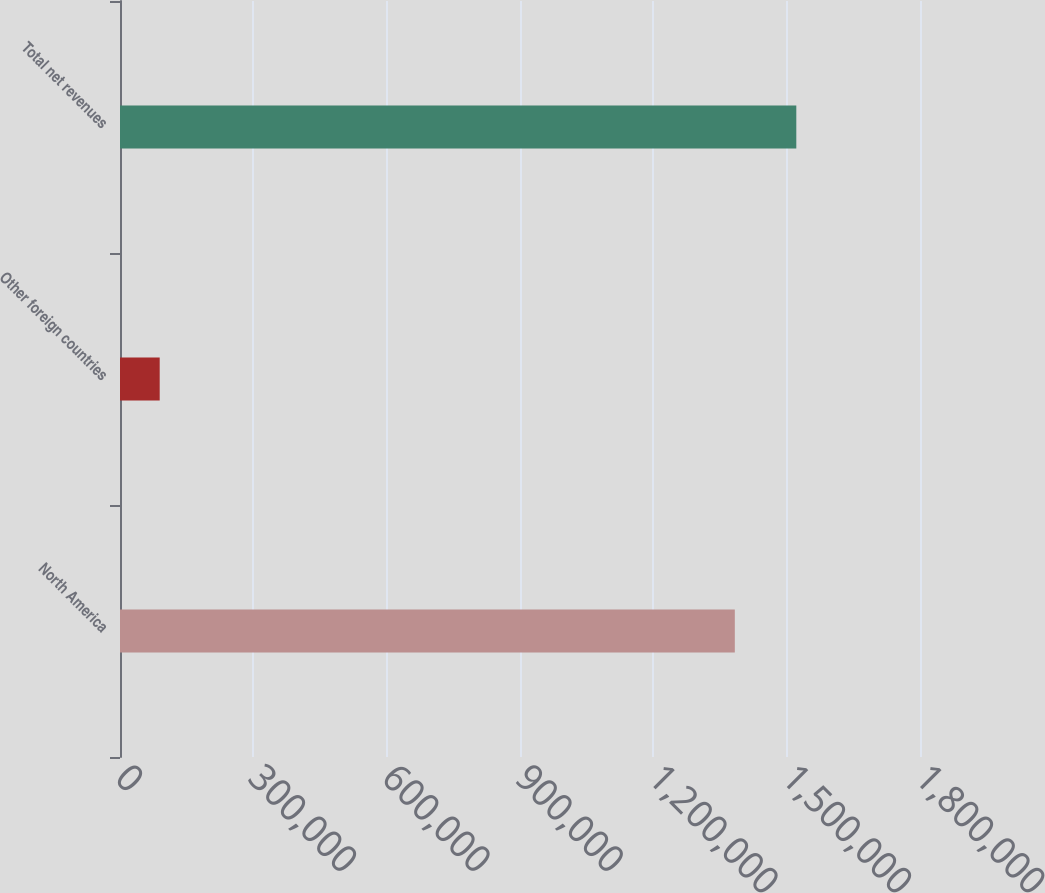Convert chart to OTSL. <chart><loc_0><loc_0><loc_500><loc_500><bar_chart><fcel>North America<fcel>Other foreign countries<fcel>Total net revenues<nl><fcel>1.38335e+06<fcel>89338<fcel>1.52168e+06<nl></chart> 